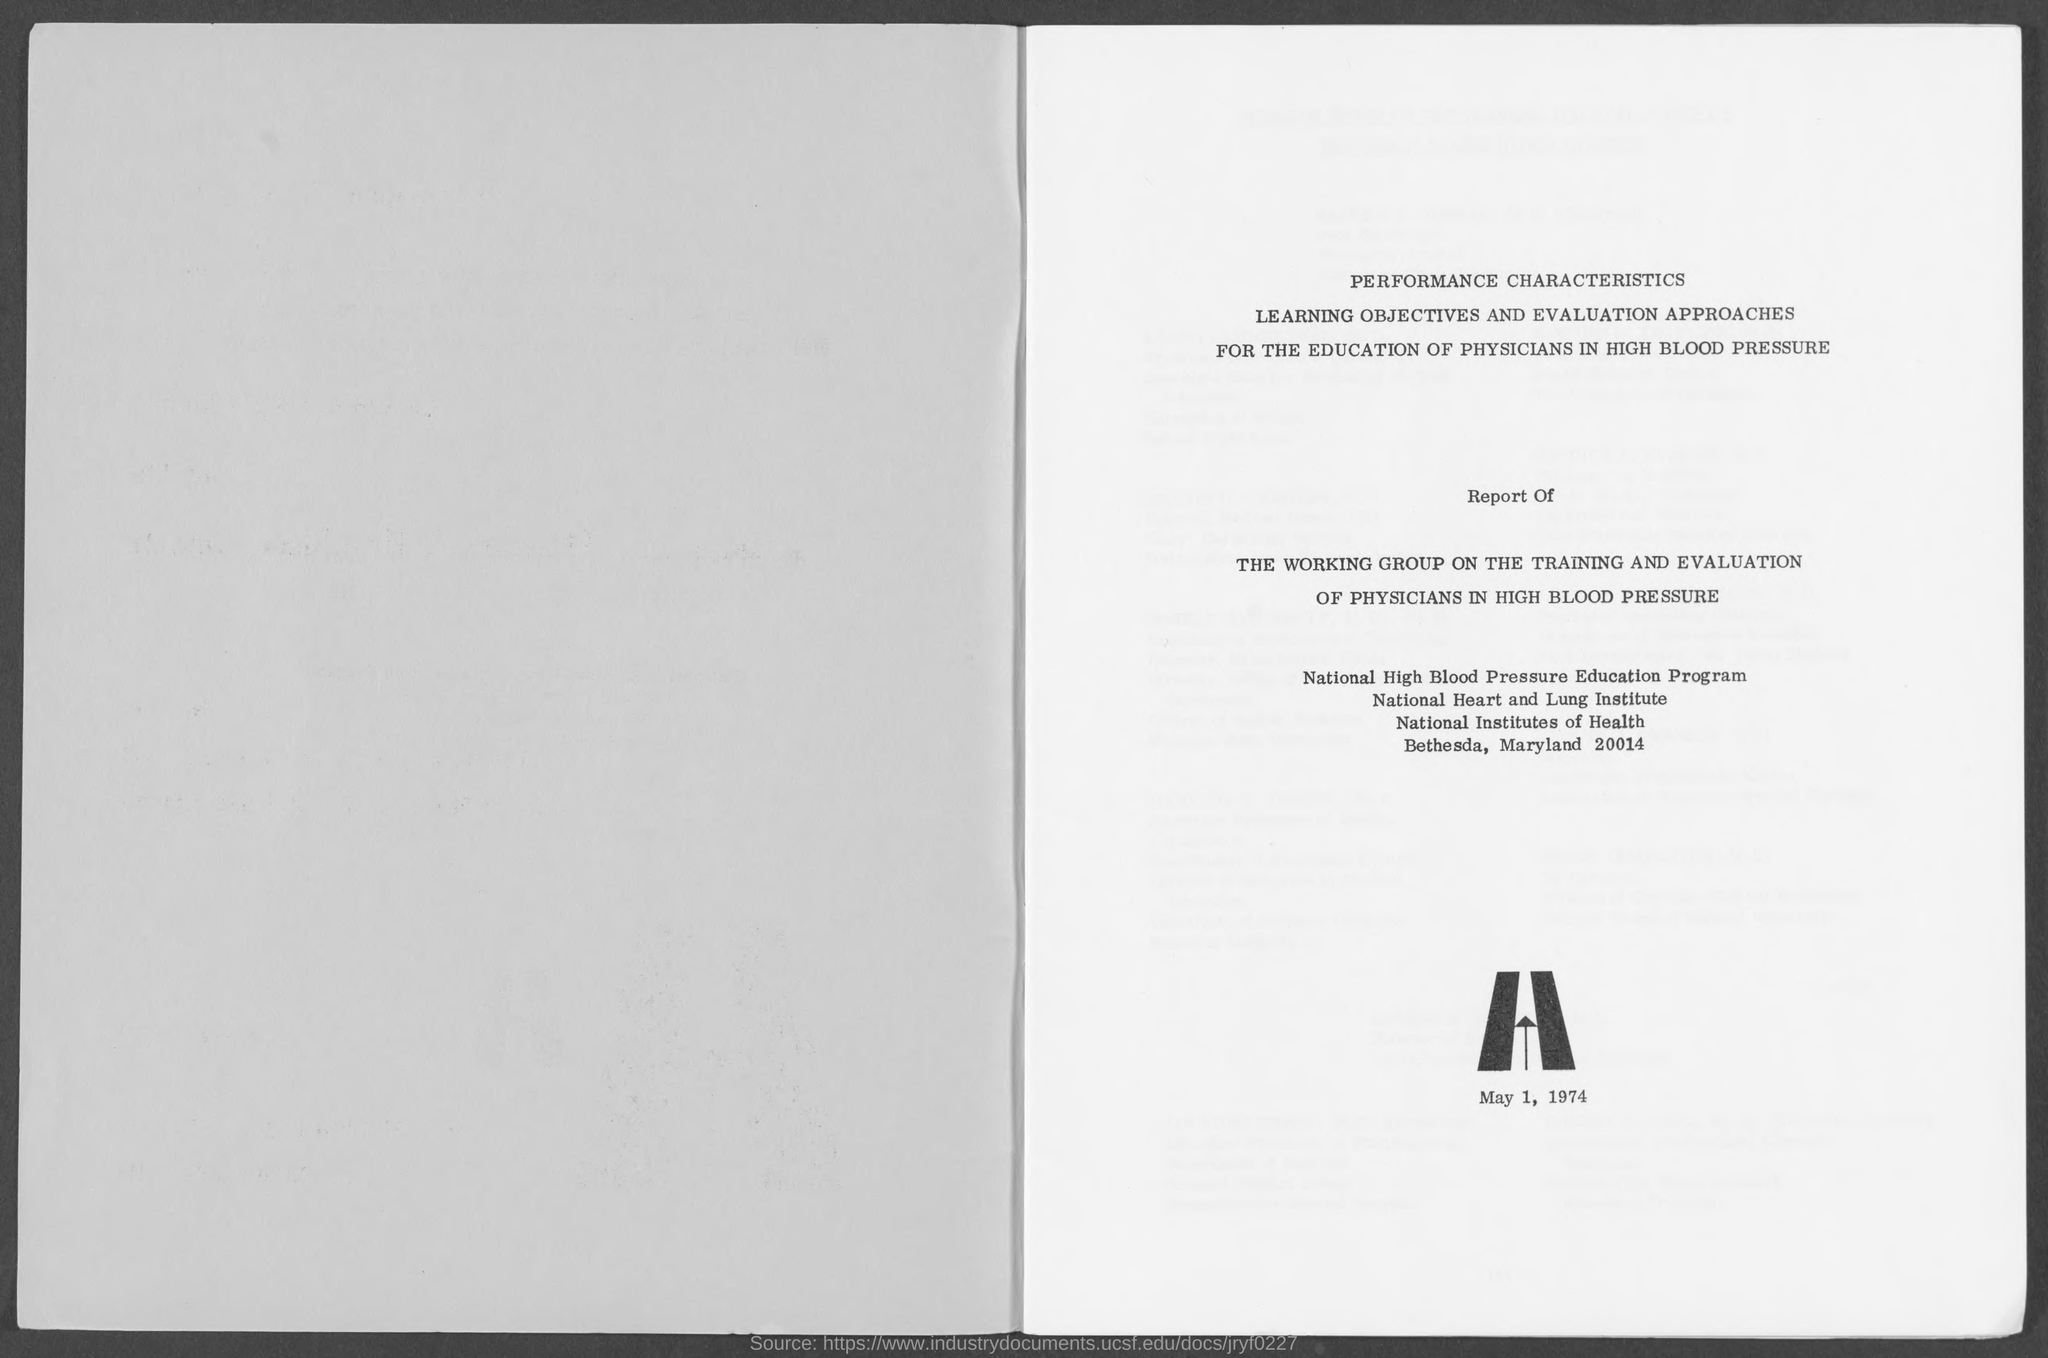Draw attention to some important aspects in this diagram. The National High Blood Pressure Education Program is the name of an education program. The date in the document is May 1, 1974. 